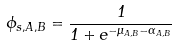Convert formula to latex. <formula><loc_0><loc_0><loc_500><loc_500>\phi _ { s , A , B } = \frac { 1 } { 1 + e ^ { - \mu _ { A , B } - \alpha _ { A , B } } }</formula> 